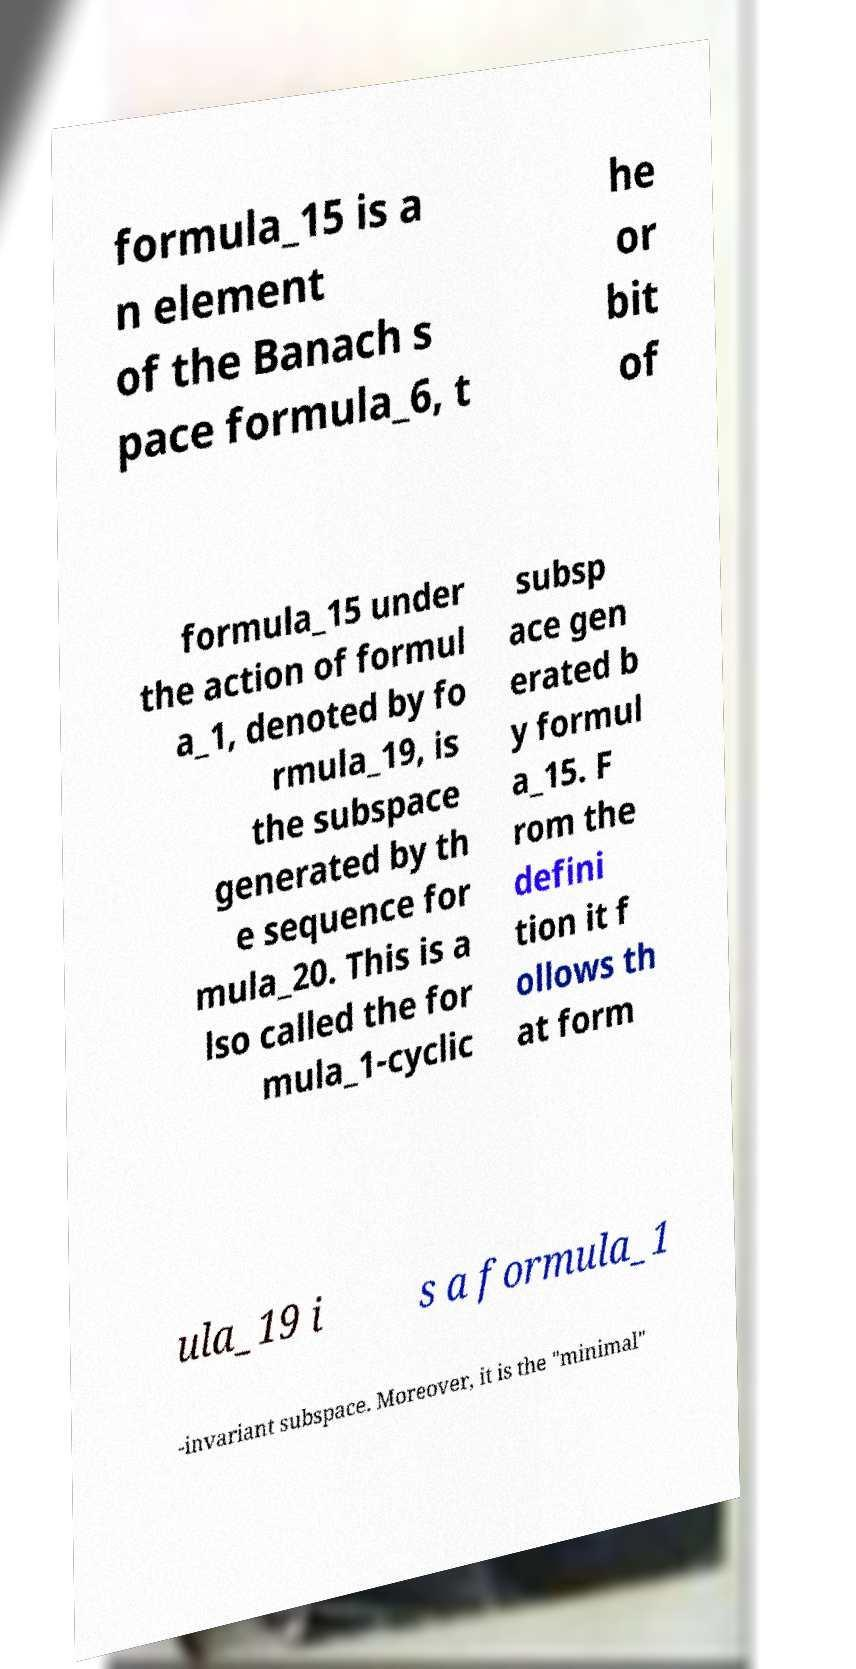Please read and relay the text visible in this image. What does it say? formula_15 is a n element of the Banach s pace formula_6, t he or bit of formula_15 under the action of formul a_1, denoted by fo rmula_19, is the subspace generated by th e sequence for mula_20. This is a lso called the for mula_1-cyclic subsp ace gen erated b y formul a_15. F rom the defini tion it f ollows th at form ula_19 i s a formula_1 -invariant subspace. Moreover, it is the "minimal" 